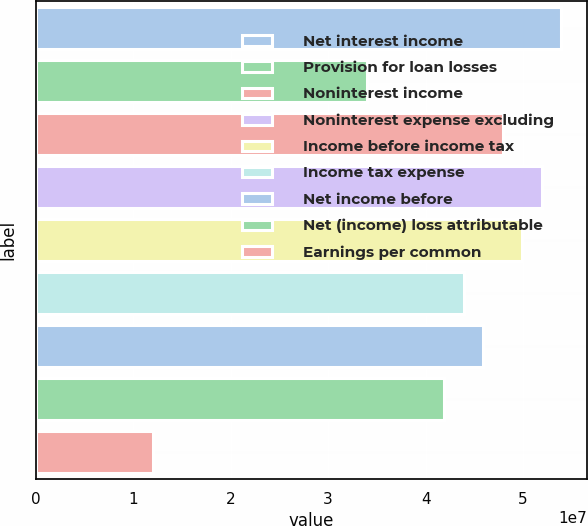Convert chart. <chart><loc_0><loc_0><loc_500><loc_500><bar_chart><fcel>Net interest income<fcel>Provision for loan losses<fcel>Noninterest income<fcel>Noninterest expense excluding<fcel>Income before income tax<fcel>Income tax expense<fcel>Net income before<fcel>Net (income) loss attributable<fcel>Earnings per common<nl><fcel>5.3916e+07<fcel>3.39471e+07<fcel>4.79253e+07<fcel>5.19191e+07<fcel>4.99222e+07<fcel>4.39316e+07<fcel>4.59285e+07<fcel>4.19347e+07<fcel>1.19813e+07<nl></chart> 